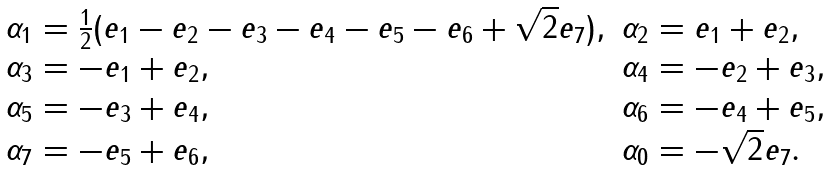Convert formula to latex. <formula><loc_0><loc_0><loc_500><loc_500>\begin{array} { l l } { { \alpha _ { 1 } = { \frac { 1 } { 2 } } ( e _ { 1 } - e _ { 2 } - e _ { 3 } - e _ { 4 } - e _ { 5 } - e _ { 6 } + \sqrt { 2 } e _ { 7 } ) , } } & { { \alpha _ { 2 } = e _ { 1 } + e _ { 2 } , } } \\ { { \alpha _ { 3 } = - e _ { 1 } + e _ { 2 } , } } & { { \alpha _ { 4 } = - e _ { 2 } + e _ { 3 } , } } \\ { { \alpha _ { 5 } = - e _ { 3 } + e _ { 4 } , } } & { { \alpha _ { 6 } = - e _ { 4 } + e _ { 5 } , } } \\ { { \alpha _ { 7 } = - e _ { 5 } + e _ { 6 } , } } & { { \alpha _ { 0 } = - \sqrt { 2 } e _ { 7 } . } } \end{array}</formula> 